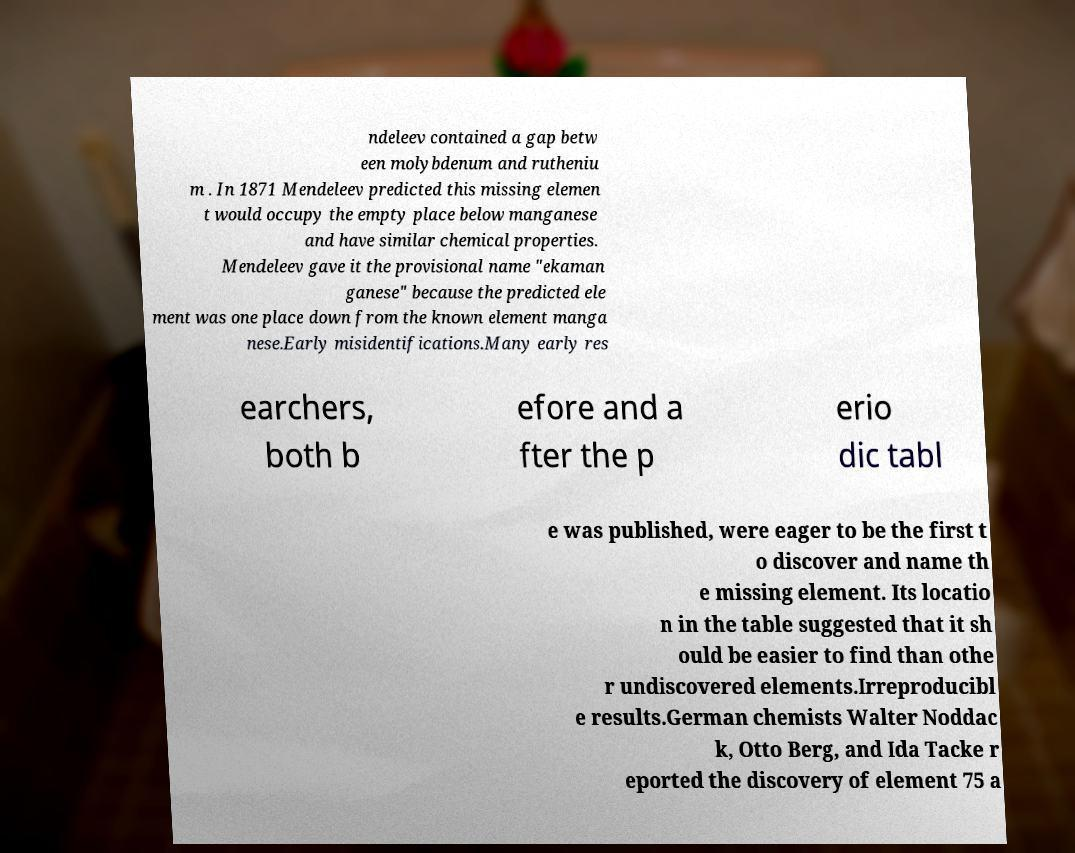Could you extract and type out the text from this image? ndeleev contained a gap betw een molybdenum and rutheniu m . In 1871 Mendeleev predicted this missing elemen t would occupy the empty place below manganese and have similar chemical properties. Mendeleev gave it the provisional name "ekaman ganese" because the predicted ele ment was one place down from the known element manga nese.Early misidentifications.Many early res earchers, both b efore and a fter the p erio dic tabl e was published, were eager to be the first t o discover and name th e missing element. Its locatio n in the table suggested that it sh ould be easier to find than othe r undiscovered elements.Irreproducibl e results.German chemists Walter Noddac k, Otto Berg, and Ida Tacke r eported the discovery of element 75 a 